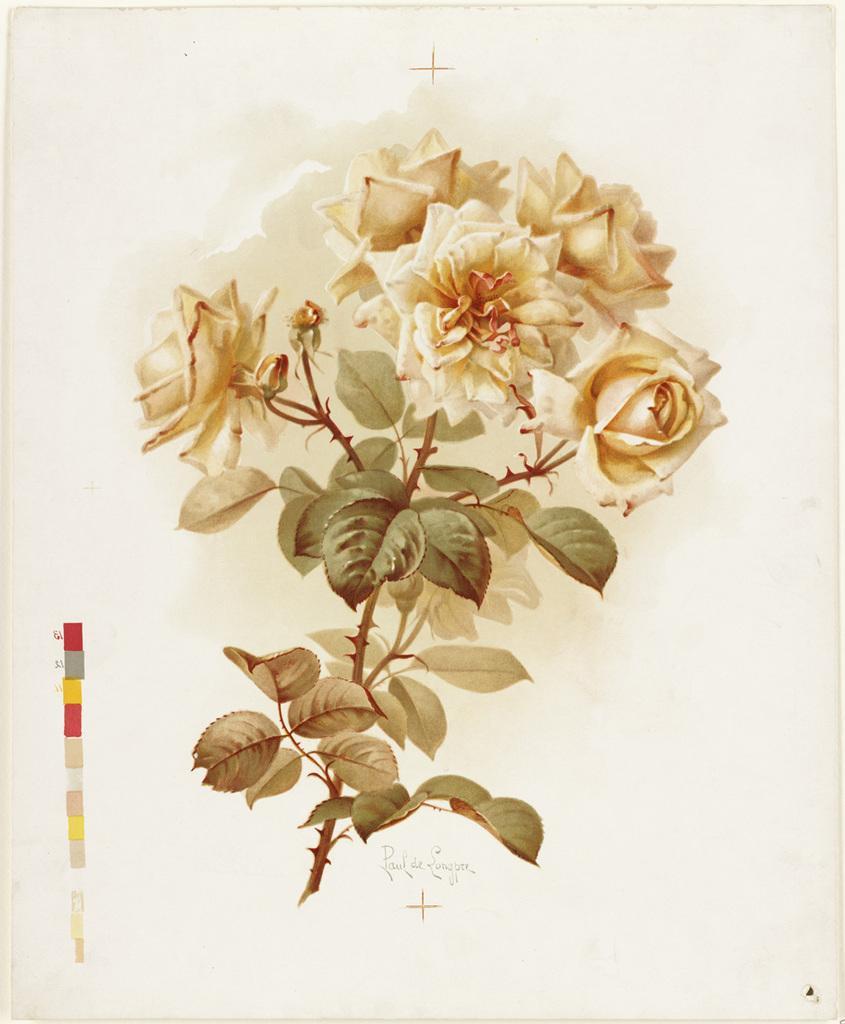Describe this image in one or two sentences. In this picture we can see some leaves and flowers in the middle, at the bottom there is some text, we can see petals of these flowers. 